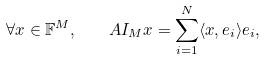Convert formula to latex. <formula><loc_0><loc_0><loc_500><loc_500>\forall x \in \mathbb { F } ^ { M } , \quad A I _ { M } x = \sum _ { i = 1 } ^ { N } \langle x , e _ { i } \rangle e _ { i } ,</formula> 